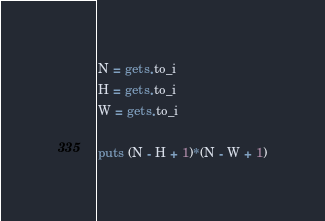<code> <loc_0><loc_0><loc_500><loc_500><_Ruby_>N = gets.to_i
H = gets.to_i
W = gets.to_i

puts (N - H + 1)*(N - W + 1)
</code> 